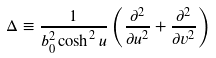Convert formula to latex. <formula><loc_0><loc_0><loc_500><loc_500>\Delta \equiv \frac { 1 } { b _ { 0 } ^ { 2 } \cosh ^ { 2 } u } \left ( \frac { { \partial } ^ { 2 } } { { \partial } u ^ { 2 } } + \frac { { \partial } ^ { 2 } } { { \partial } v ^ { 2 } } \right )</formula> 